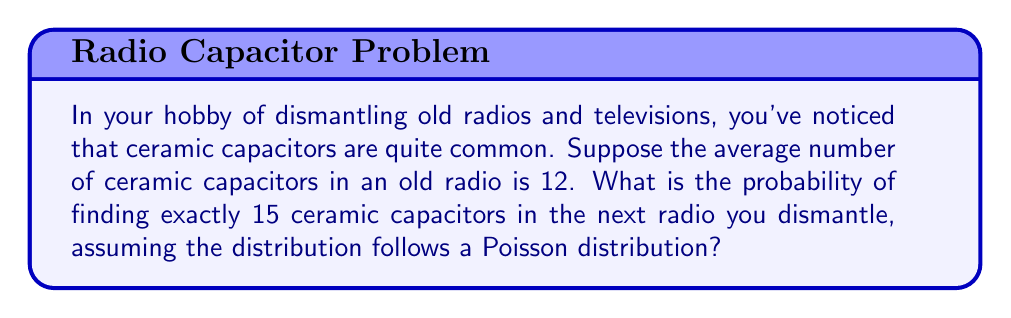Give your solution to this math problem. To solve this problem, we'll use the Poisson distribution formula:

$$P(X = k) = \frac{e^{-\lambda} \lambda^k}{k!}$$

Where:
$\lambda$ = average number of occurrences
$k$ = specific number of occurrences we're interested in
$e$ = Euler's number (approximately 2.71828)

Given:
$\lambda = 12$ (average number of ceramic capacitors)
$k = 15$ (number of ceramic capacitors we're looking for)

Step 1: Plug the values into the formula:

$$P(X = 15) = \frac{e^{-12} 12^{15}}{15!}$$

Step 2: Calculate $e^{-12}$:
$e^{-12} \approx 6.14421 \times 10^{-6}$

Step 3: Calculate $12^{15}$:
$12^{15} = 1.29746 \times 10^{16}$

Step 4: Calculate 15!:
$15! = 1,307,674,368,000$

Step 5: Plug these values into the equation:

$$P(X = 15) = \frac{(6.14421 \times 10^{-6})(1.29746 \times 10^{16})}{1,307,674,368,000}$$

Step 6: Simplify:

$$P(X = 15) \approx 0.0609$$

Therefore, the probability of finding exactly 15 ceramic capacitors in the next radio you dismantle is approximately 0.0609 or 6.09%.
Answer: $0.0609$ or $6.09\%$ 